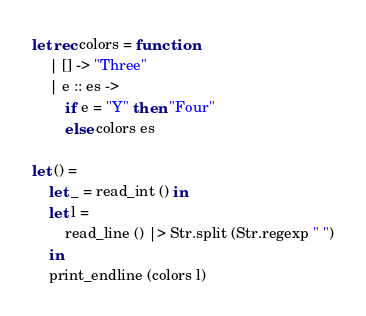Convert code to text. <code><loc_0><loc_0><loc_500><loc_500><_OCaml_>let rec colors = function
    | [] -> "Three"
    | e :: es ->
        if e = "Y" then "Four"
        else colors es

let () =
    let _ = read_int () in
    let l =
        read_line () |> Str.split (Str.regexp " ")
    in
    print_endline (colors l)
</code> 